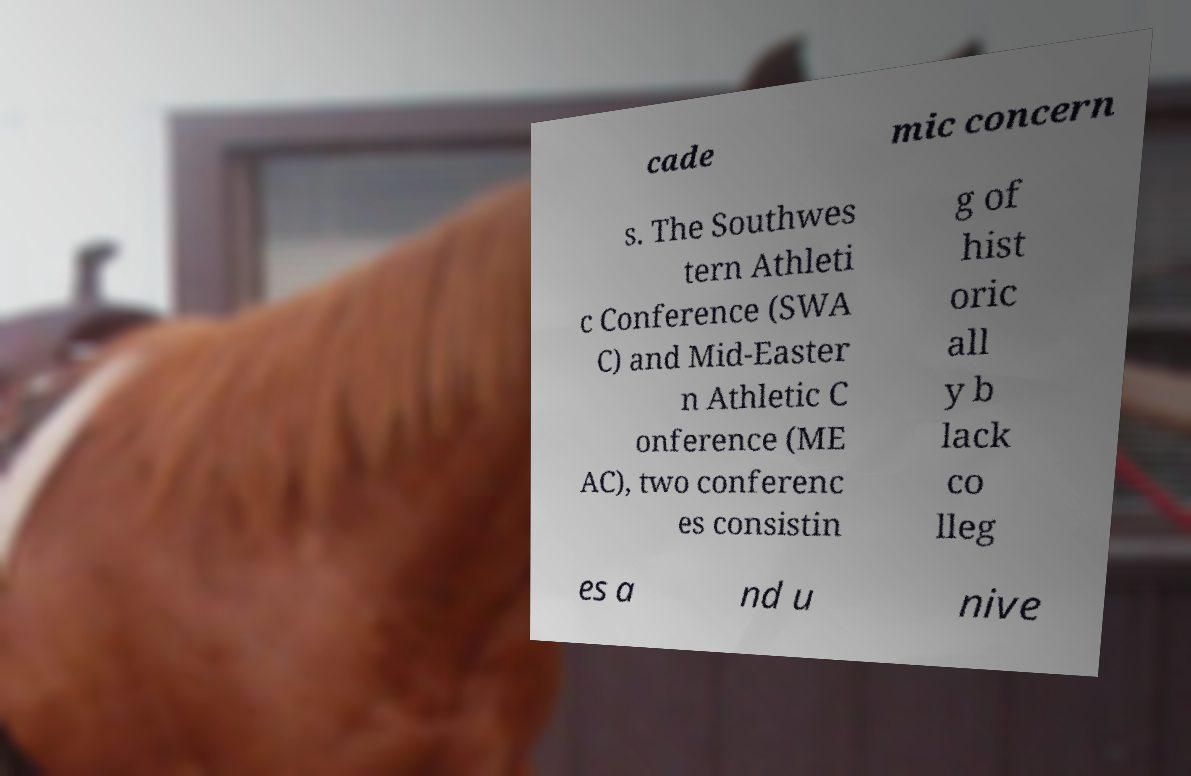Can you accurately transcribe the text from the provided image for me? cade mic concern s. The Southwes tern Athleti c Conference (SWA C) and Mid-Easter n Athletic C onference (ME AC), two conferenc es consistin g of hist oric all y b lack co lleg es a nd u nive 